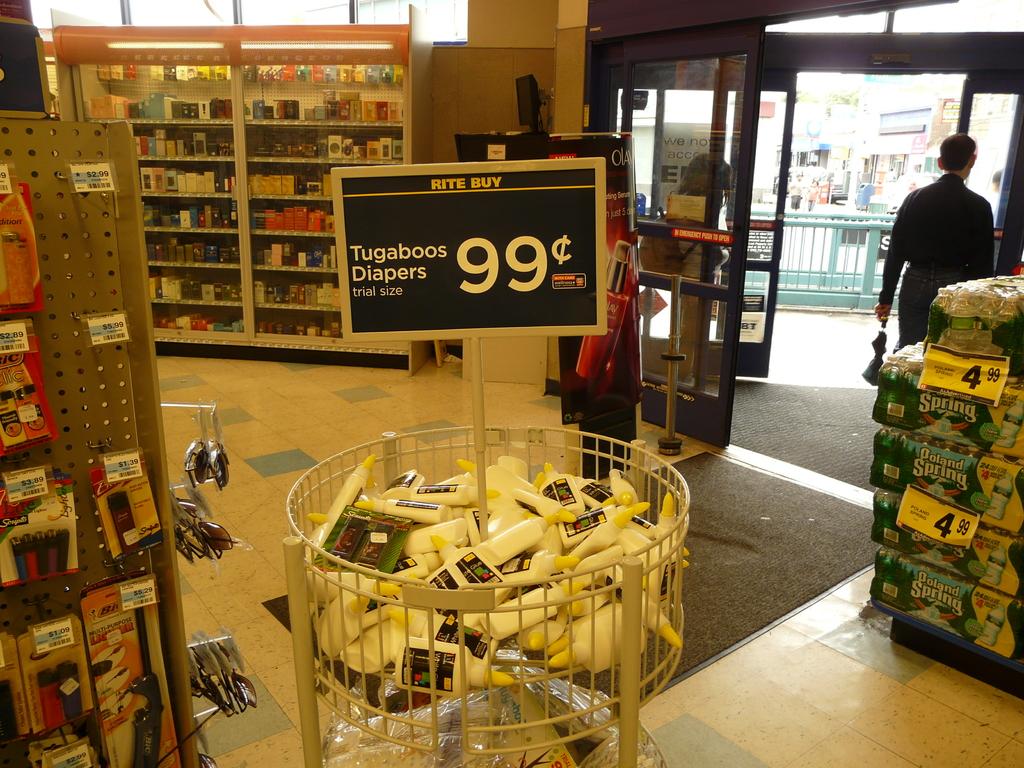What discount is in the bin?
Provide a succinct answer. Tugaboos diapers. How much do the items in the bin cost?
Offer a terse response. 99 cents. 